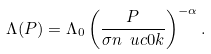Convert formula to latex. <formula><loc_0><loc_0><loc_500><loc_500>\Lambda ( P ) = \Lambda _ { 0 } \left ( \frac { P } { \sigma n \ u { c 0 } k } \right ) ^ { - \alpha } .</formula> 